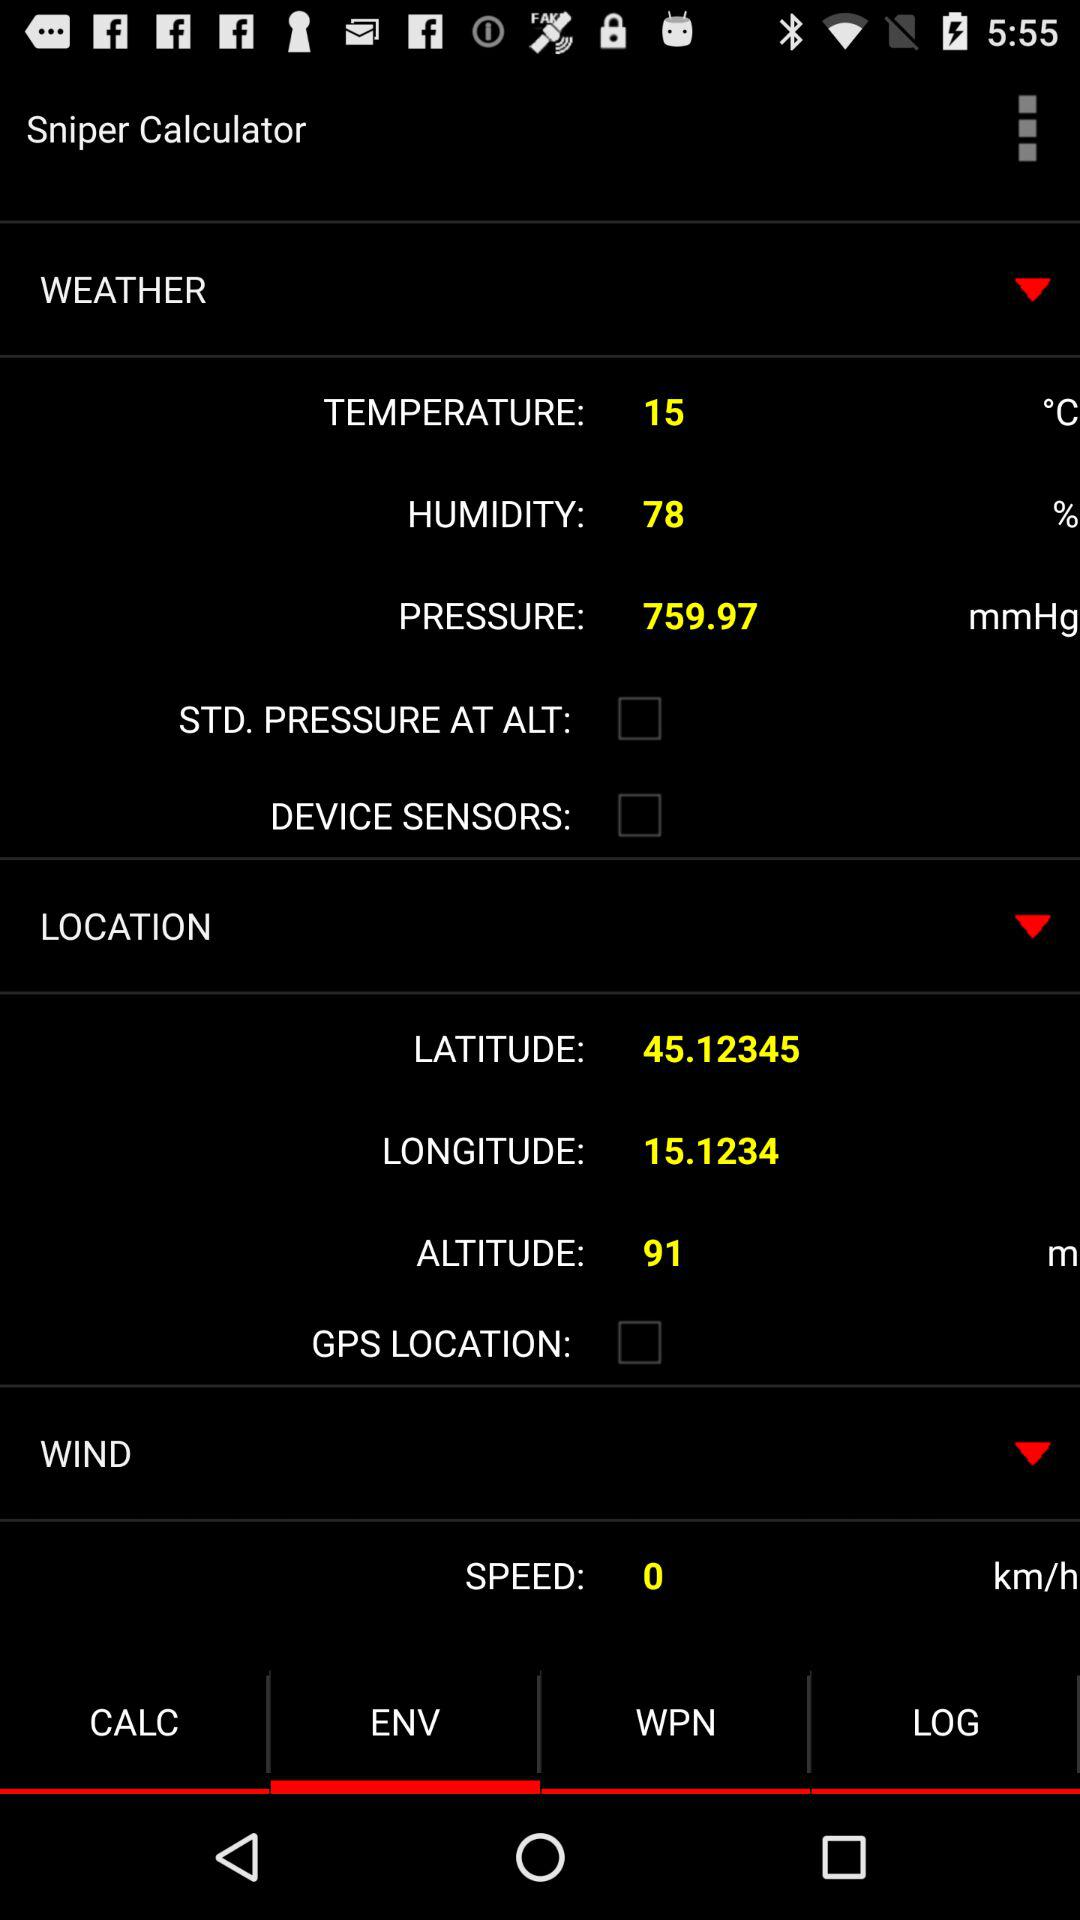What is the humidity? The humidity is 78%. 